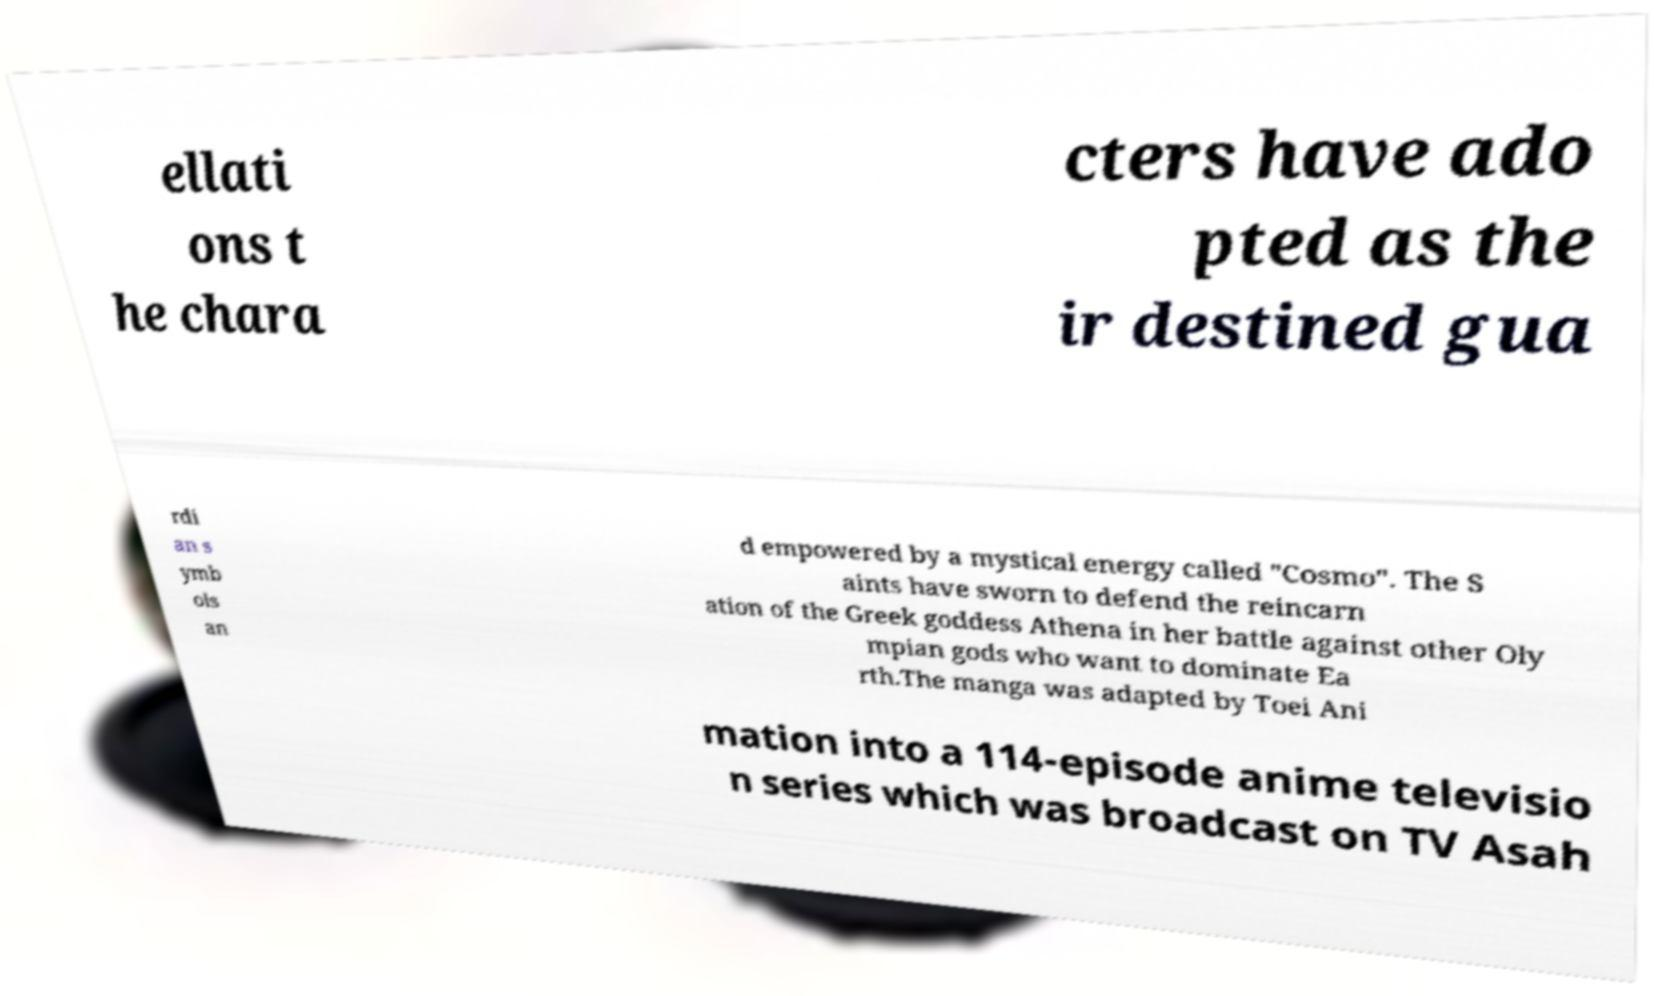Could you extract and type out the text from this image? ellati ons t he chara cters have ado pted as the ir destined gua rdi an s ymb ols an d empowered by a mystical energy called "Cosmo". The S aints have sworn to defend the reincarn ation of the Greek goddess Athena in her battle against other Oly mpian gods who want to dominate Ea rth.The manga was adapted by Toei Ani mation into a 114-episode anime televisio n series which was broadcast on TV Asah 